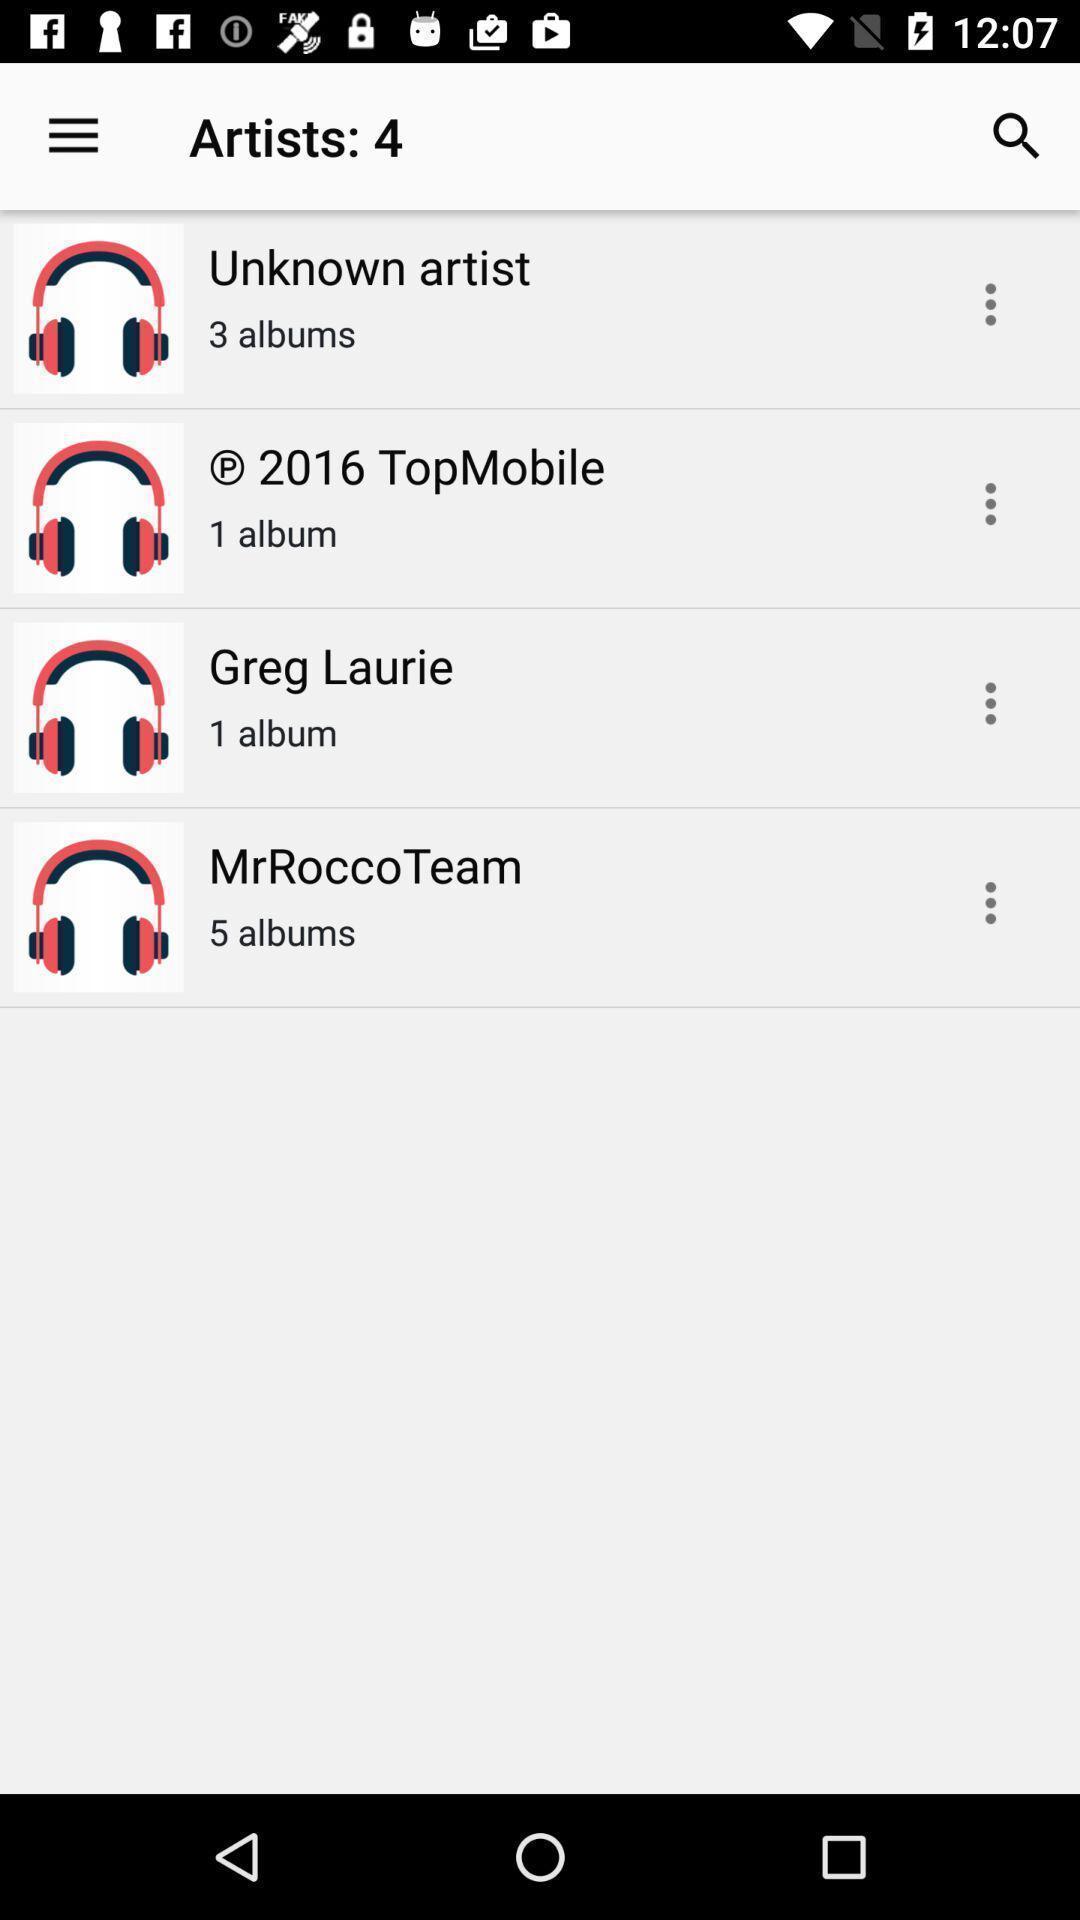Explain the elements present in this screenshot. Page showing list of songs in a music app. 